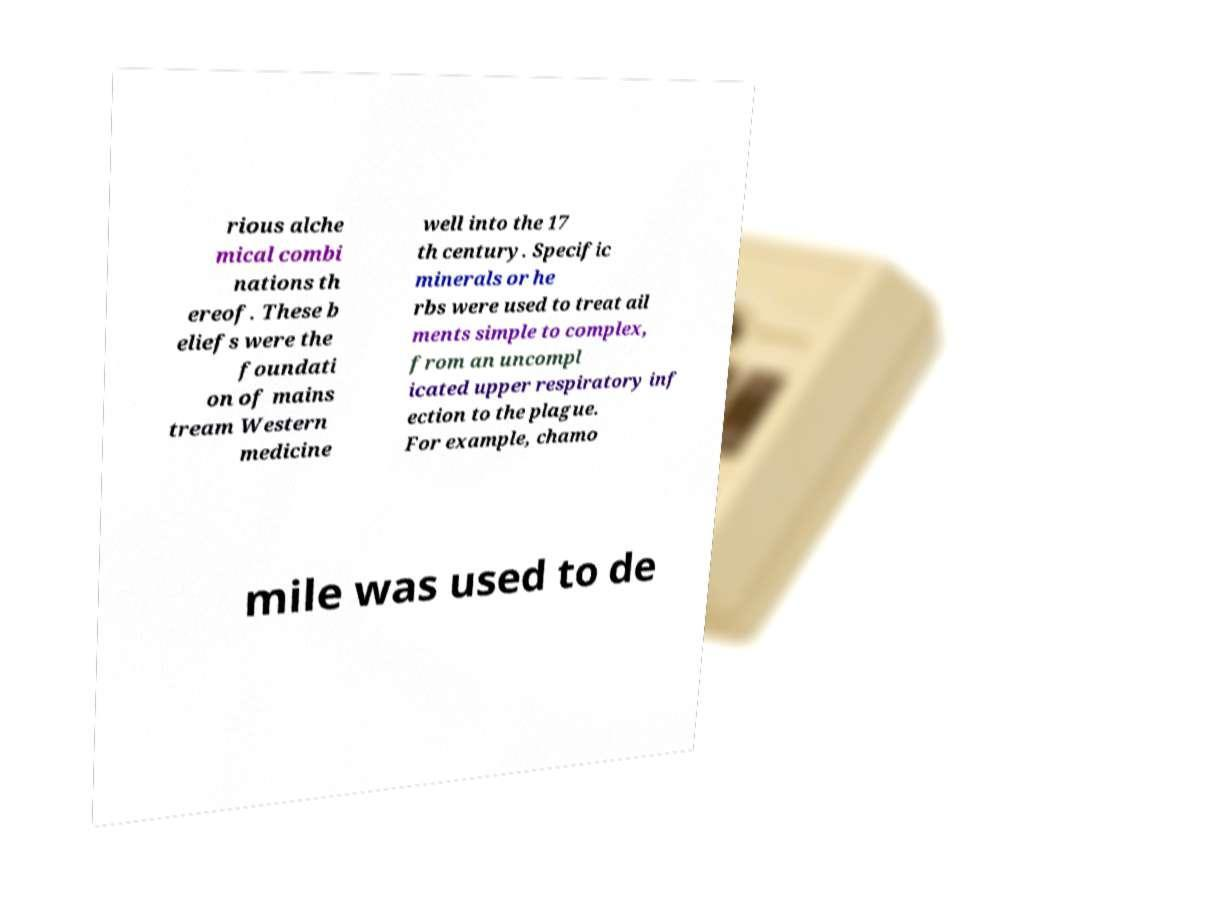Can you accurately transcribe the text from the provided image for me? rious alche mical combi nations th ereof. These b eliefs were the foundati on of mains tream Western medicine well into the 17 th century. Specific minerals or he rbs were used to treat ail ments simple to complex, from an uncompl icated upper respiratory inf ection to the plague. For example, chamo mile was used to de 